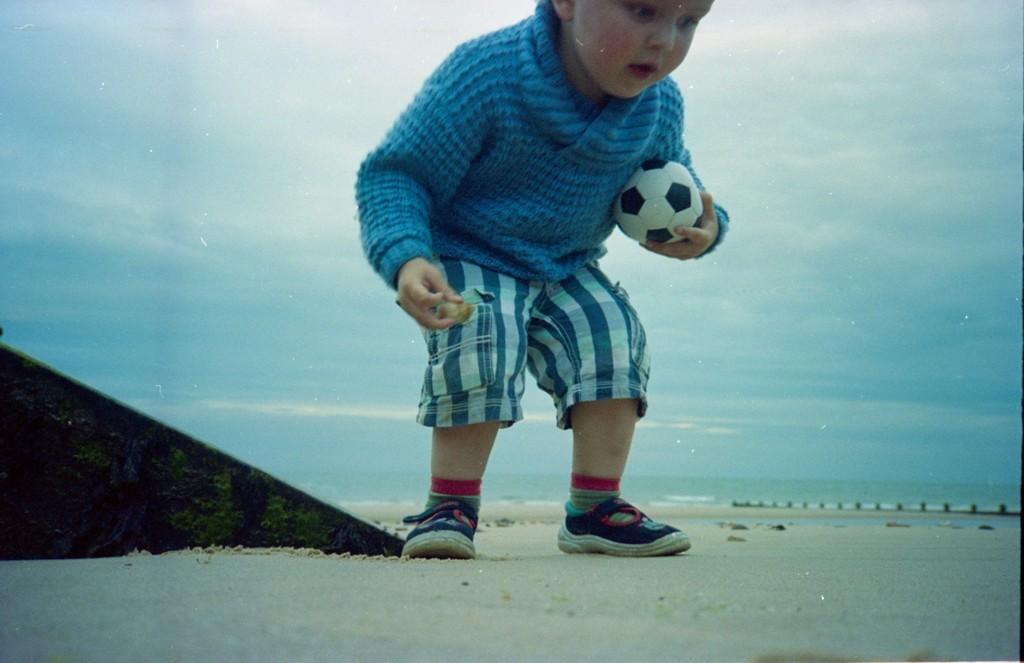Who is in the picture? There is a boy in the picture. What is the boy doing in the picture? The boy is standing in the picture. What is the boy holding in his hand? The boy is holding a ball in his left hand. What can be seen in the background of the image? There is a water body in the background of the image. What is the condition of the sky in the picture? The sky is clear in the picture. What type of bottle is the boy using to control the water in the image? There is no bottle or water present in the image; it only features a boy standing and holding a ball. 